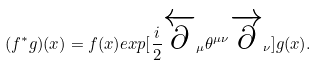Convert formula to latex. <formula><loc_0><loc_0><loc_500><loc_500>( f ^ { * } g ) ( x ) = f ( x ) e x p [ \frac { i } { 2 } \overleftarrow { \partial } _ { \mu } \theta ^ { \mu \nu } \overrightarrow { \partial } _ { \nu } ] g ( x ) .</formula> 